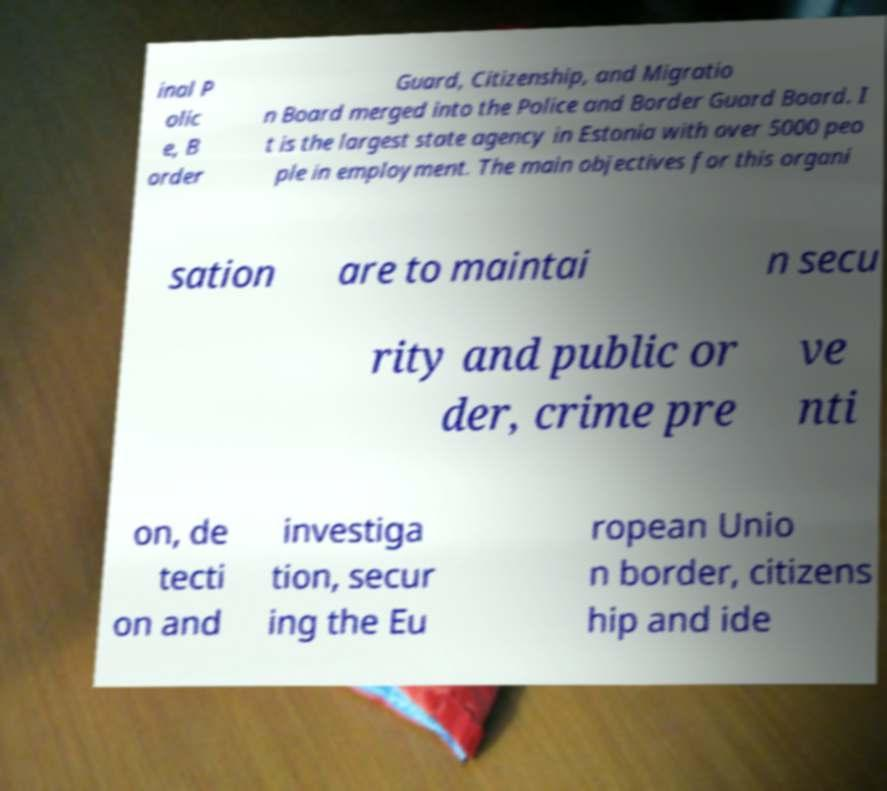Can you read and provide the text displayed in the image?This photo seems to have some interesting text. Can you extract and type it out for me? inal P olic e, B order Guard, Citizenship, and Migratio n Board merged into the Police and Border Guard Board. I t is the largest state agency in Estonia with over 5000 peo ple in employment. The main objectives for this organi sation are to maintai n secu rity and public or der, crime pre ve nti on, de tecti on and investiga tion, secur ing the Eu ropean Unio n border, citizens hip and ide 